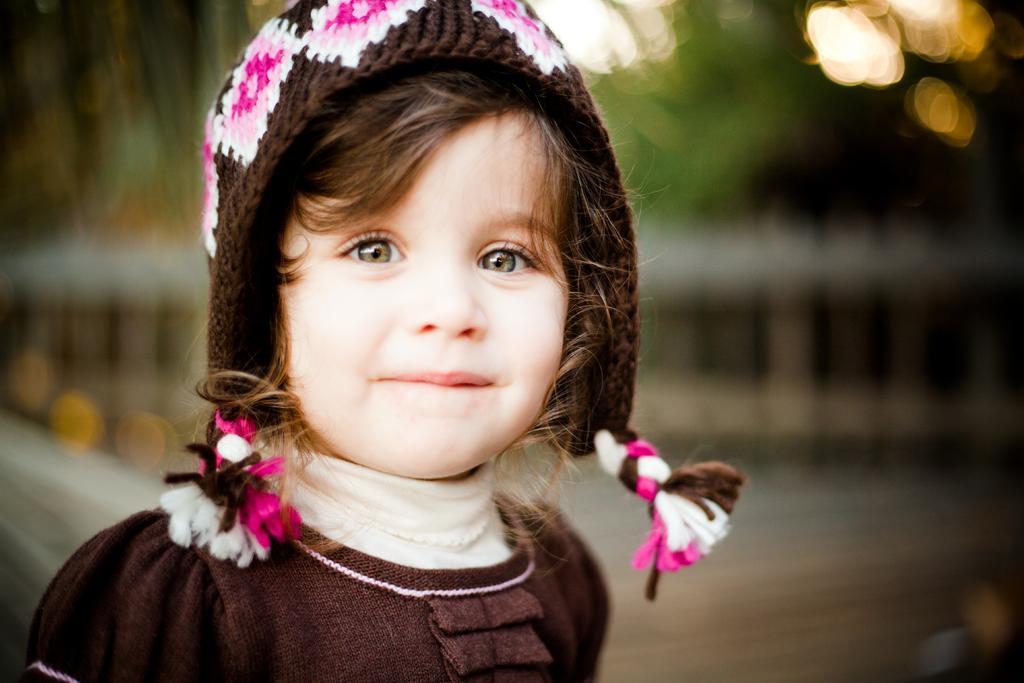Could you give a brief overview of what you see in this image? In this picture I can observe a girl. This girl is smiling. She is wearing brown color dress and a cap on her head. The background is completely blurred. 